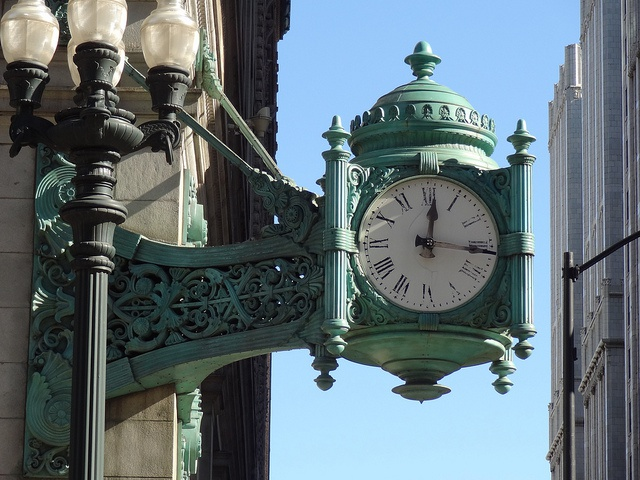Describe the objects in this image and their specific colors. I can see a clock in black and gray tones in this image. 